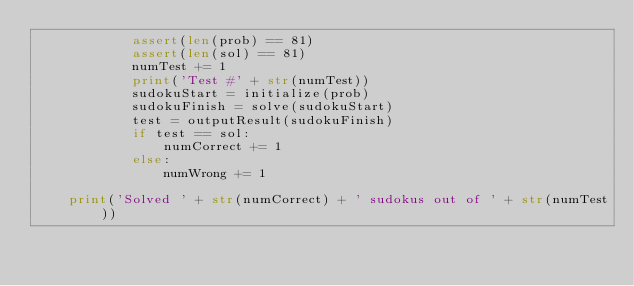<code> <loc_0><loc_0><loc_500><loc_500><_Python_>            assert(len(prob) == 81)
            assert(len(sol) == 81)
            numTest += 1
            print('Test #' + str(numTest))
            sudokuStart = initialize(prob)
            sudokuFinish = solve(sudokuStart)
            test = outputResult(sudokuFinish)
            if test == sol:
                numCorrect += 1
            else:
                numWrong += 1

    print('Solved ' + str(numCorrect) + ' sudokus out of ' + str(numTest))

</code> 